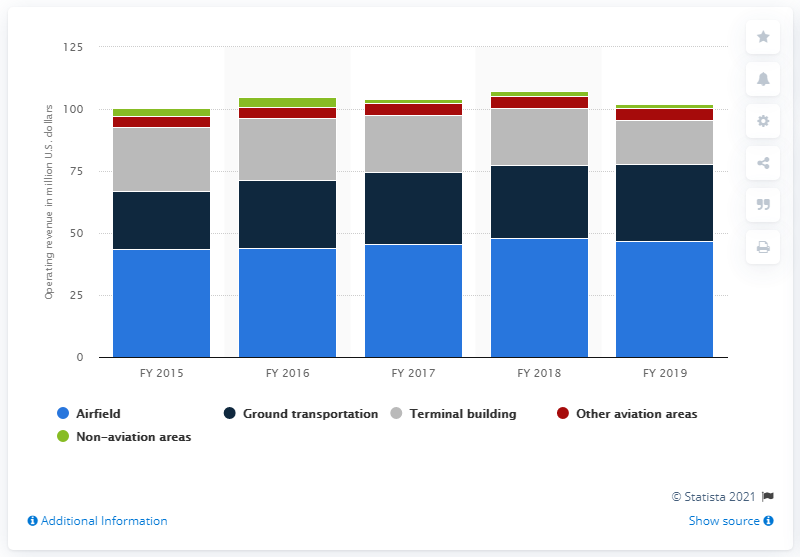Indicate a few pertinent items in this graphic. The Memphis Shelby County Airport generated 18.05 million dollars from terminal building operations in the past year. The Memphis Shelby County Airport generated approximately $46.59 million in revenue from airfield operations in a given time period. 